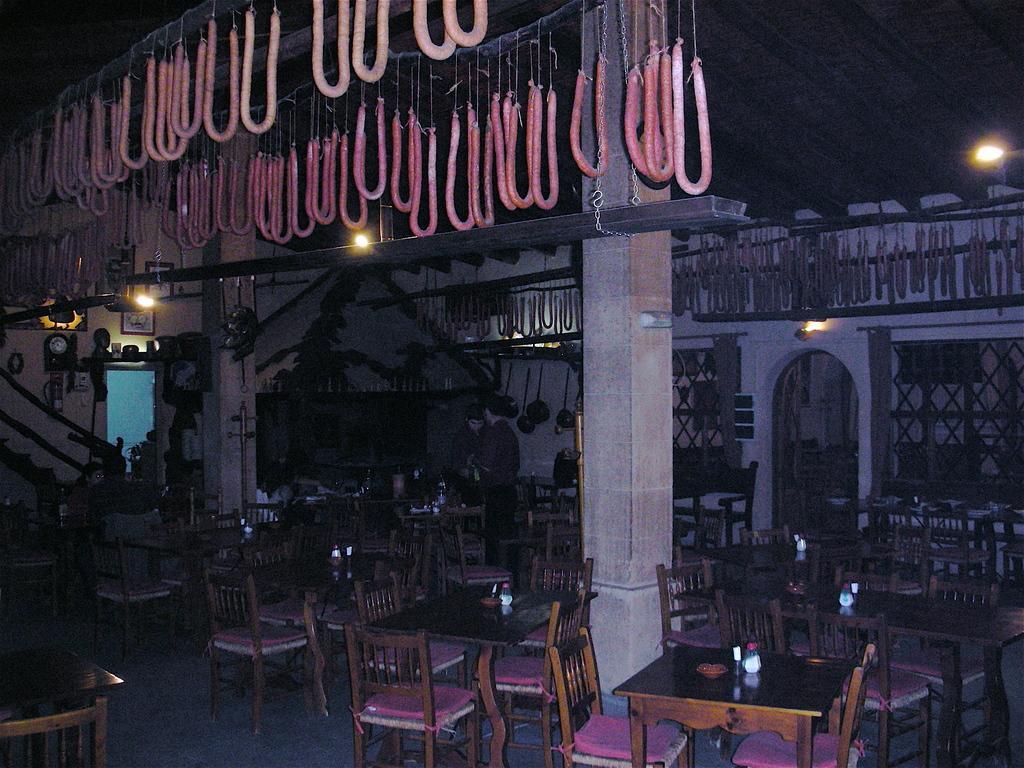In one or two sentences, can you explain what this image depicts? In this image we can see few chairs and tables, there are few objects on the tables and there are few people, there are few lights and objects hanged to the ceiling, there is a staircase and there are few objects to the wall. 